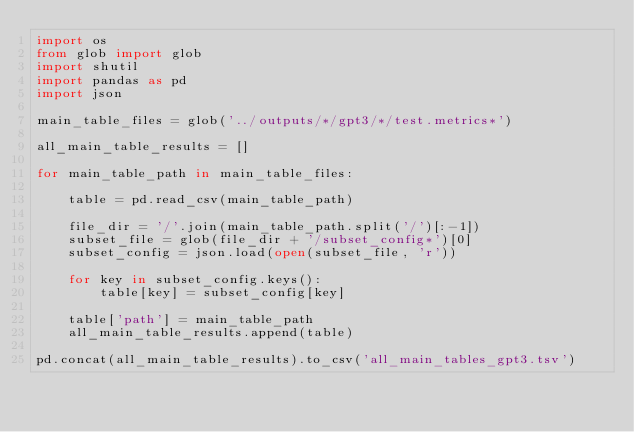Convert code to text. <code><loc_0><loc_0><loc_500><loc_500><_Python_>import os
from glob import glob
import shutil
import pandas as pd
import json

main_table_files = glob('../outputs/*/gpt3/*/test.metrics*')

all_main_table_results = []

for main_table_path in main_table_files:

    table = pd.read_csv(main_table_path)

    file_dir = '/'.join(main_table_path.split('/')[:-1])
    subset_file = glob(file_dir + '/subset_config*')[0]
    subset_config = json.load(open(subset_file, 'r'))

    for key in subset_config.keys():
        table[key] = subset_config[key]

    table['path'] = main_table_path
    all_main_table_results.append(table)

pd.concat(all_main_table_results).to_csv('all_main_tables_gpt3.tsv')</code> 